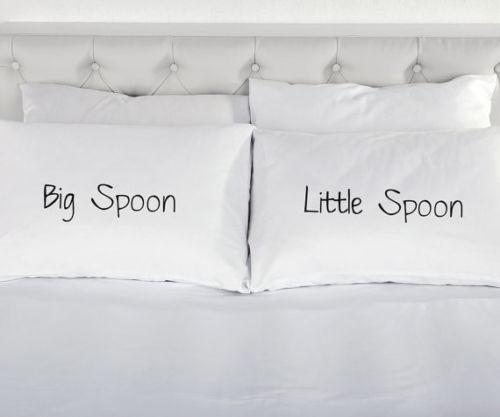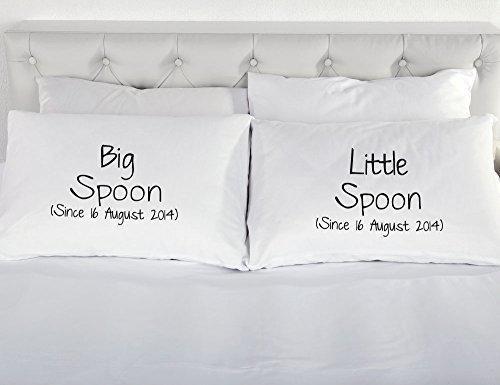The first image is the image on the left, the second image is the image on the right. For the images shown, is this caption "There are more pillows in the image on the left than in the image on the right." true? Answer yes or no. No. 